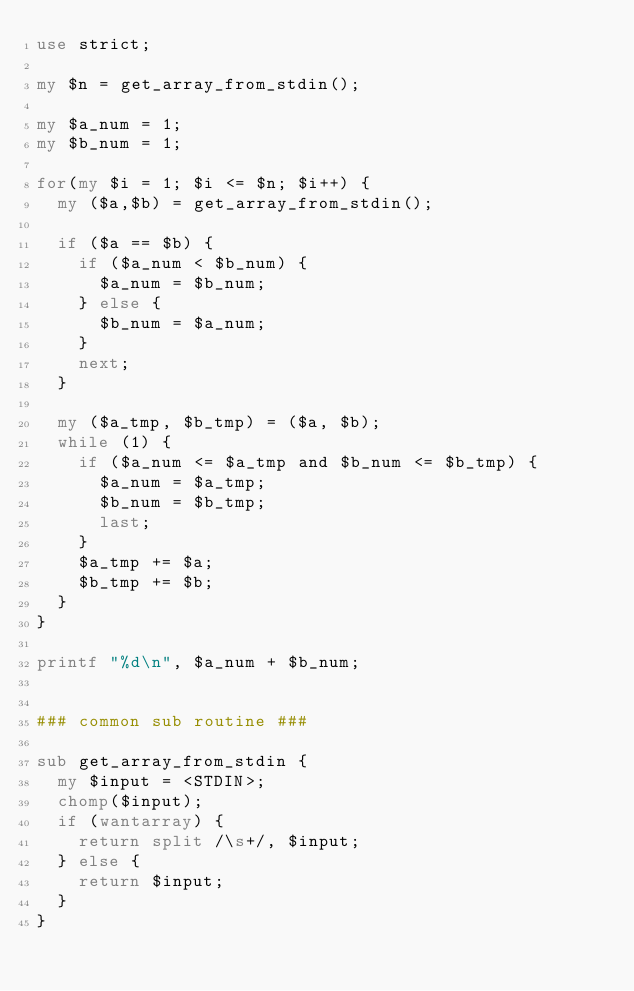Convert code to text. <code><loc_0><loc_0><loc_500><loc_500><_Perl_>use strict;

my $n = get_array_from_stdin();

my $a_num = 1;
my $b_num = 1;

for(my $i = 1; $i <= $n; $i++) {
  my ($a,$b) = get_array_from_stdin();

  if ($a == $b) {
    if ($a_num < $b_num) {
      $a_num = $b_num;
    } else {
      $b_num = $a_num;
    }
    next;
  }

  my ($a_tmp, $b_tmp) = ($a, $b);
  while (1) {
    if ($a_num <= $a_tmp and $b_num <= $b_tmp) {
      $a_num = $a_tmp;
      $b_num = $b_tmp;
      last;
    }
    $a_tmp += $a;
    $b_tmp += $b;
  }
}

printf "%d\n", $a_num + $b_num;


### common sub routine ###

sub get_array_from_stdin {
  my $input = <STDIN>;
  chomp($input);
  if (wantarray) {
    return split /\s+/, $input;
  } else {
    return $input;
  }
}
</code> 